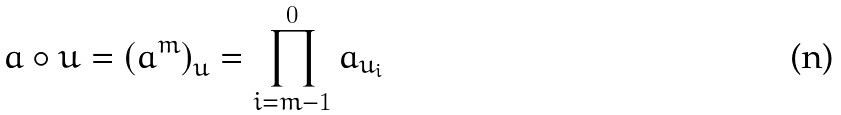<formula> <loc_0><loc_0><loc_500><loc_500>a \circ u = \left ( a ^ { m } \right ) _ { u } = \prod _ { i = m - 1 } ^ { 0 } a _ { u _ { i } }</formula> 